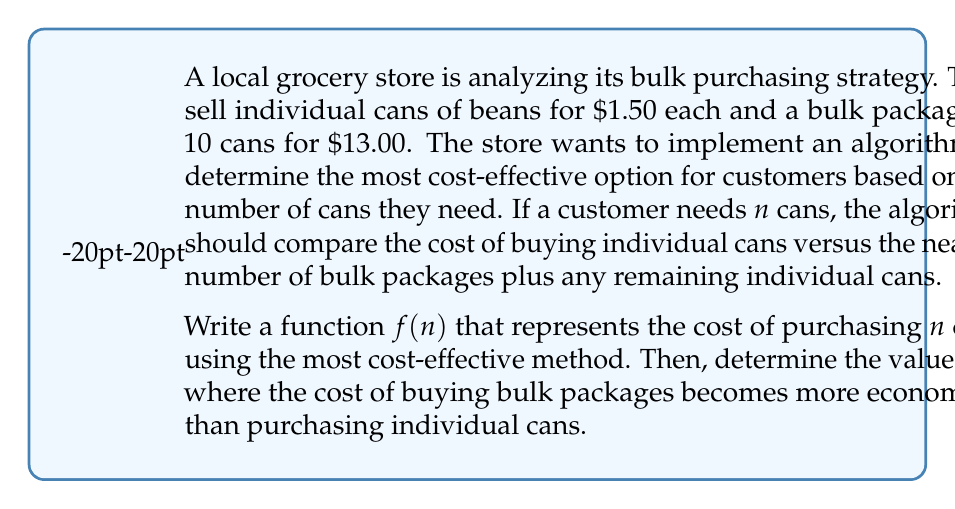What is the answer to this math problem? Let's approach this step-by-step:

1) First, we need to define our function $f(n)$:

   $$f(n) = \min(\text{cost of individual cans}, \text{cost of bulk + remaining individual cans})$$

2) Cost of individual cans is straightforward: $1.50n$

3) For bulk packages, we need to calculate:
   - Number of bulk packages: $\lfloor \frac{n}{10} \rfloor$
   - Remaining individual cans: $n \bmod 10$
   
   So, the cost of bulk + remaining individual cans is:
   $$13.00 \cdot \lfloor \frac{n}{10} \rfloor + 1.50 \cdot (n \bmod 10)$$

4) Therefore, our function $f(n)$ can be written as:

   $$f(n) = \min(1.50n, 13.00 \cdot \lfloor \frac{n}{10} \rfloor + 1.50 \cdot (n \bmod 10))$$

5) To find where bulk becomes more economical, we need to find the smallest $n$ where:

   $$13.00 \cdot \lfloor \frac{n}{10} \rfloor + 1.50 \cdot (n \bmod 10) < 1.50n$$

6) We can solve this by checking values of $n$ incrementally:

   For $n = 9$:
   Individual: $1.50 \cdot 9 = 13.50$
   Bulk: $13.00 \cdot 0 + 1.50 \cdot 9 = 13.50$

   For $n = 10$:
   Individual: $1.50 \cdot 10 = 15.00$
   Bulk: $13.00 \cdot 1 + 1.50 \cdot 0 = 13.00$

7) Therefore, bulk purchasing becomes more economical when $n = 10$.
Answer: The function $f(n)$ representing the most cost-effective purchasing method is:

$$f(n) = \min(1.50n, 13.00 \cdot \lfloor \frac{n}{10} \rfloor + 1.50 \cdot (n \bmod 10))$$

Bulk purchasing becomes more economical than individual can purchases when $n = 10$. 